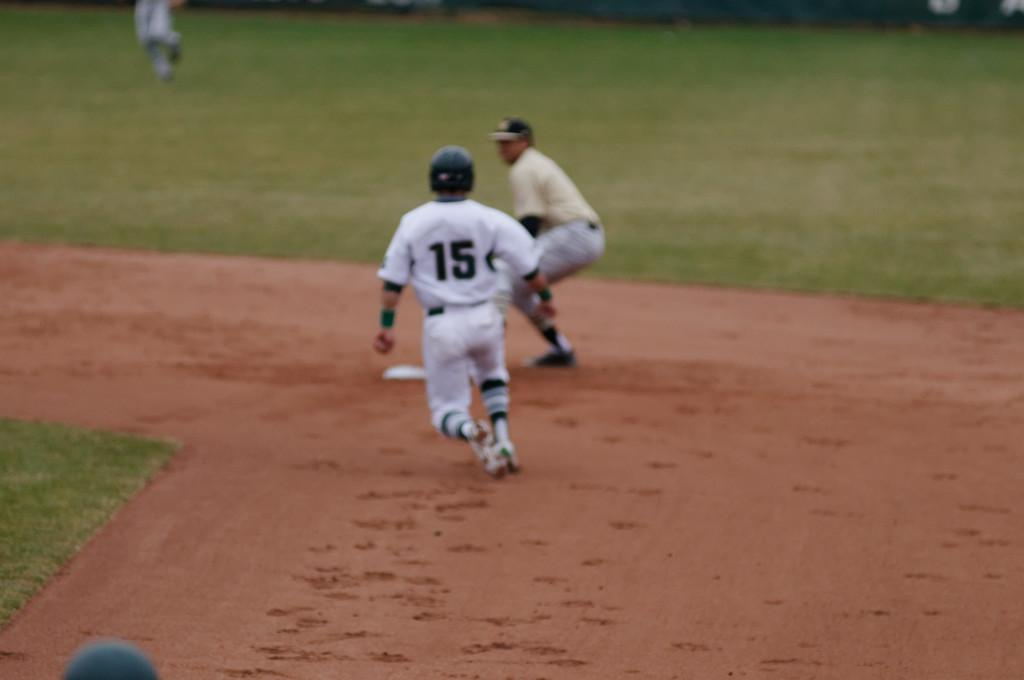<image>
Give a short and clear explanation of the subsequent image. number 15 of the white team is running toward the base 